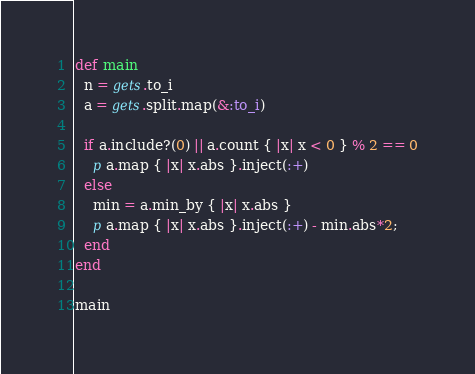<code> <loc_0><loc_0><loc_500><loc_500><_Ruby_>def main
  n = gets.to_i
  a = gets.split.map(&:to_i)

  if a.include?(0) || a.count { |x| x < 0 } % 2 == 0
    p a.map { |x| x.abs }.inject(:+)
  else
    min = a.min_by { |x| x.abs }
    p a.map { |x| x.abs }.inject(:+) - min.abs*2;
  end
end

main
</code> 